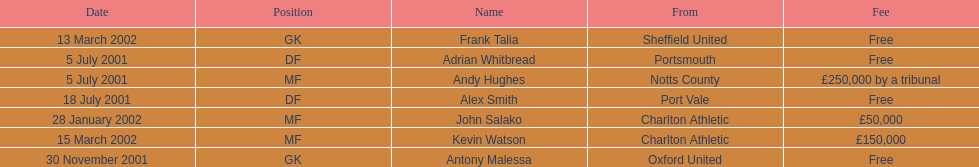Who transferred before 1 august 2001? Andy Hughes, Adrian Whitbread, Alex Smith. 